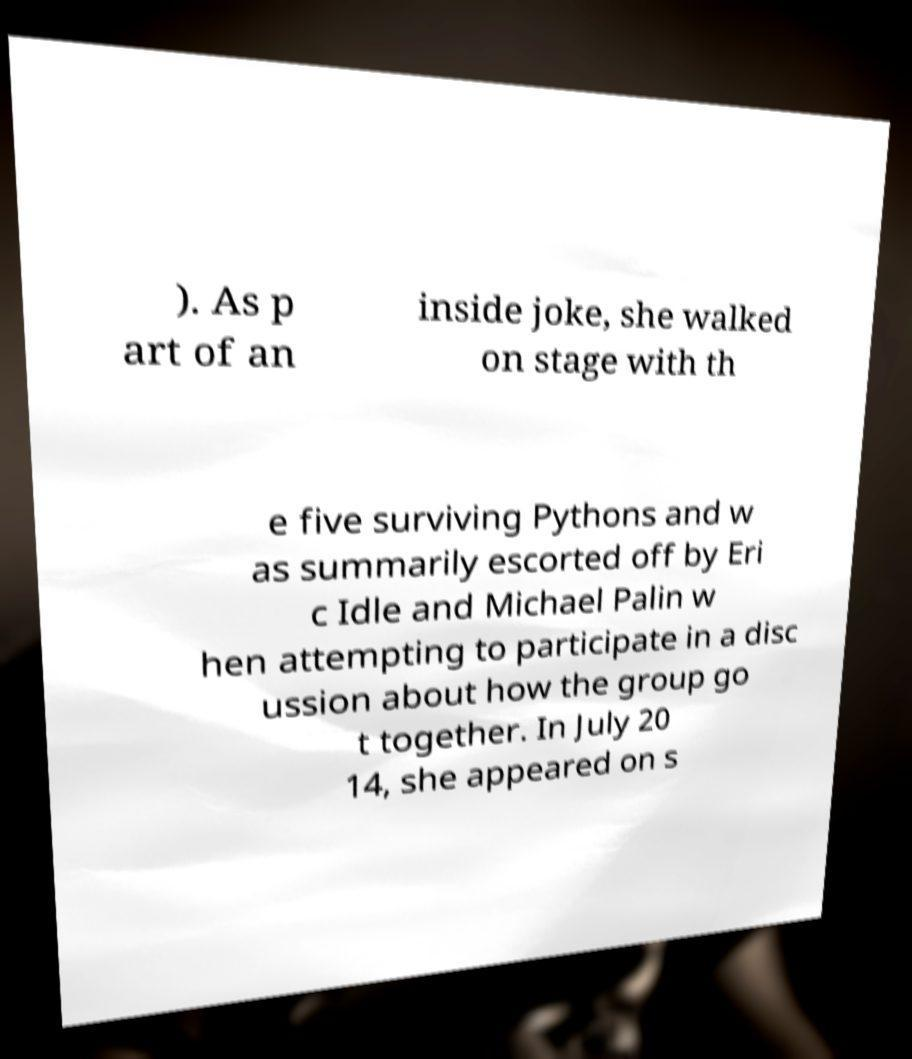Could you extract and type out the text from this image? ). As p art of an inside joke, she walked on stage with th e five surviving Pythons and w as summarily escorted off by Eri c Idle and Michael Palin w hen attempting to participate in a disc ussion about how the group go t together. In July 20 14, she appeared on s 